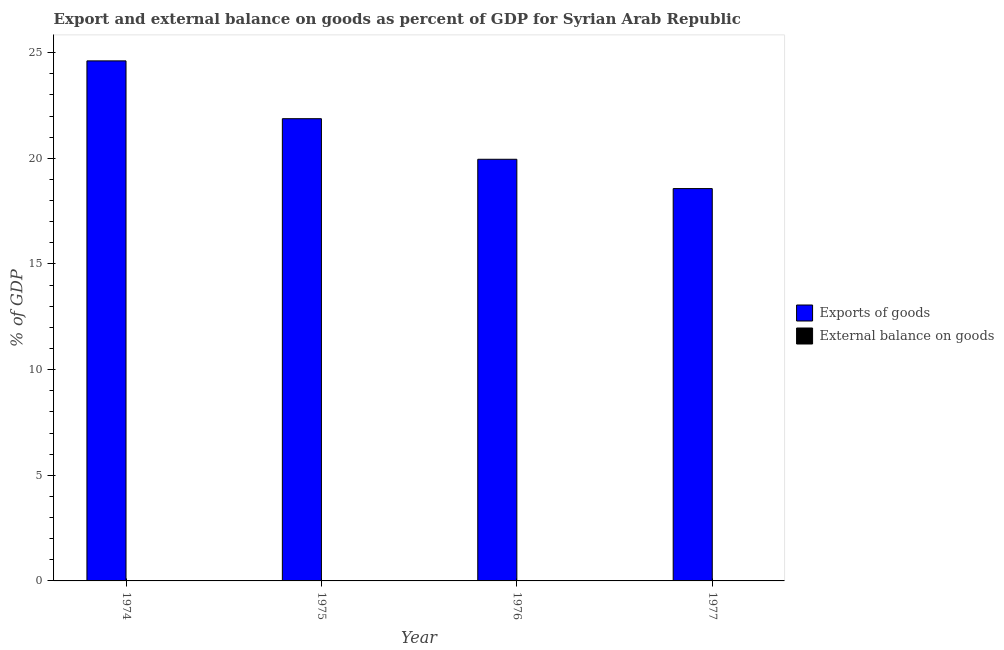How many different coloured bars are there?
Offer a terse response. 1. Are the number of bars on each tick of the X-axis equal?
Ensure brevity in your answer.  Yes. How many bars are there on the 4th tick from the right?
Offer a very short reply. 1. What is the label of the 3rd group of bars from the left?
Offer a very short reply. 1976. In how many cases, is the number of bars for a given year not equal to the number of legend labels?
Keep it short and to the point. 4. Across all years, what is the maximum export of goods as percentage of gdp?
Provide a succinct answer. 24.61. Across all years, what is the minimum external balance on goods as percentage of gdp?
Your answer should be compact. 0. In which year was the export of goods as percentage of gdp maximum?
Keep it short and to the point. 1974. What is the total export of goods as percentage of gdp in the graph?
Ensure brevity in your answer.  85.02. What is the difference between the export of goods as percentage of gdp in 1974 and that in 1975?
Ensure brevity in your answer.  2.74. What is the difference between the export of goods as percentage of gdp in 1976 and the external balance on goods as percentage of gdp in 1975?
Offer a terse response. -1.92. What is the average external balance on goods as percentage of gdp per year?
Offer a terse response. 0. In how many years, is the external balance on goods as percentage of gdp greater than 13 %?
Your response must be concise. 0. What is the difference between the highest and the second highest export of goods as percentage of gdp?
Ensure brevity in your answer.  2.74. What is the difference between the highest and the lowest export of goods as percentage of gdp?
Ensure brevity in your answer.  6.04. In how many years, is the export of goods as percentage of gdp greater than the average export of goods as percentage of gdp taken over all years?
Your response must be concise. 2. Is the sum of the export of goods as percentage of gdp in 1974 and 1976 greater than the maximum external balance on goods as percentage of gdp across all years?
Provide a short and direct response. Yes. How many bars are there?
Offer a very short reply. 4. How many years are there in the graph?
Your response must be concise. 4. What is the difference between two consecutive major ticks on the Y-axis?
Keep it short and to the point. 5. Are the values on the major ticks of Y-axis written in scientific E-notation?
Your answer should be very brief. No. Does the graph contain grids?
Offer a very short reply. No. How many legend labels are there?
Your response must be concise. 2. What is the title of the graph?
Make the answer very short. Export and external balance on goods as percent of GDP for Syrian Arab Republic. What is the label or title of the Y-axis?
Keep it short and to the point. % of GDP. What is the % of GDP of Exports of goods in 1974?
Your answer should be very brief. 24.61. What is the % of GDP in Exports of goods in 1975?
Offer a very short reply. 21.88. What is the % of GDP in External balance on goods in 1975?
Provide a short and direct response. 0. What is the % of GDP in Exports of goods in 1976?
Keep it short and to the point. 19.96. What is the % of GDP in Exports of goods in 1977?
Provide a short and direct response. 18.57. What is the % of GDP in External balance on goods in 1977?
Offer a very short reply. 0. Across all years, what is the maximum % of GDP in Exports of goods?
Provide a succinct answer. 24.61. Across all years, what is the minimum % of GDP of Exports of goods?
Ensure brevity in your answer.  18.57. What is the total % of GDP of Exports of goods in the graph?
Your response must be concise. 85.02. What is the total % of GDP of External balance on goods in the graph?
Your answer should be very brief. 0. What is the difference between the % of GDP of Exports of goods in 1974 and that in 1975?
Keep it short and to the point. 2.74. What is the difference between the % of GDP of Exports of goods in 1974 and that in 1976?
Your response must be concise. 4.66. What is the difference between the % of GDP of Exports of goods in 1974 and that in 1977?
Your response must be concise. 6.04. What is the difference between the % of GDP in Exports of goods in 1975 and that in 1976?
Offer a terse response. 1.92. What is the difference between the % of GDP in Exports of goods in 1975 and that in 1977?
Make the answer very short. 3.31. What is the difference between the % of GDP of Exports of goods in 1976 and that in 1977?
Your answer should be compact. 1.39. What is the average % of GDP of Exports of goods per year?
Ensure brevity in your answer.  21.25. What is the ratio of the % of GDP in Exports of goods in 1974 to that in 1975?
Keep it short and to the point. 1.13. What is the ratio of the % of GDP in Exports of goods in 1974 to that in 1976?
Keep it short and to the point. 1.23. What is the ratio of the % of GDP of Exports of goods in 1974 to that in 1977?
Provide a succinct answer. 1.33. What is the ratio of the % of GDP in Exports of goods in 1975 to that in 1976?
Offer a very short reply. 1.1. What is the ratio of the % of GDP in Exports of goods in 1975 to that in 1977?
Your answer should be very brief. 1.18. What is the ratio of the % of GDP of Exports of goods in 1976 to that in 1977?
Make the answer very short. 1.07. What is the difference between the highest and the second highest % of GDP of Exports of goods?
Provide a succinct answer. 2.74. What is the difference between the highest and the lowest % of GDP in Exports of goods?
Make the answer very short. 6.04. 